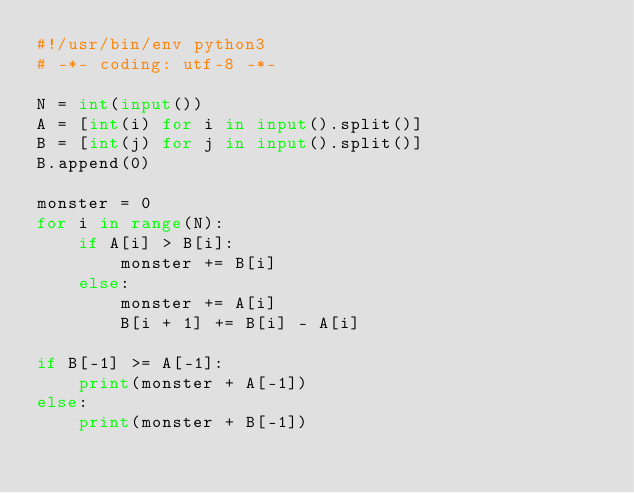<code> <loc_0><loc_0><loc_500><loc_500><_Python_>#!/usr/bin/env python3
# -*- coding: utf-8 -*-

N = int(input())
A = [int(i) for i in input().split()]
B = [int(j) for j in input().split()]
B.append(0)

monster = 0
for i in range(N):
    if A[i] > B[i]:
        monster += B[i]
    else:
        monster += A[i]
        B[i + 1] += B[i] - A[i]

if B[-1] >= A[-1]:
    print(monster + A[-1])
else:
    print(monster + B[-1])</code> 